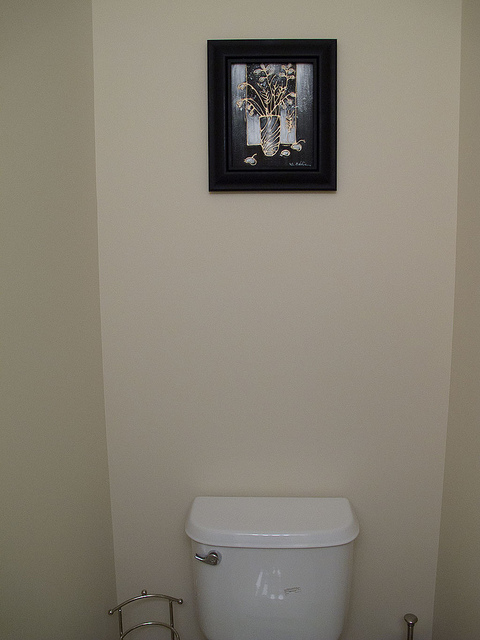How many pictures are on the wall? 1 